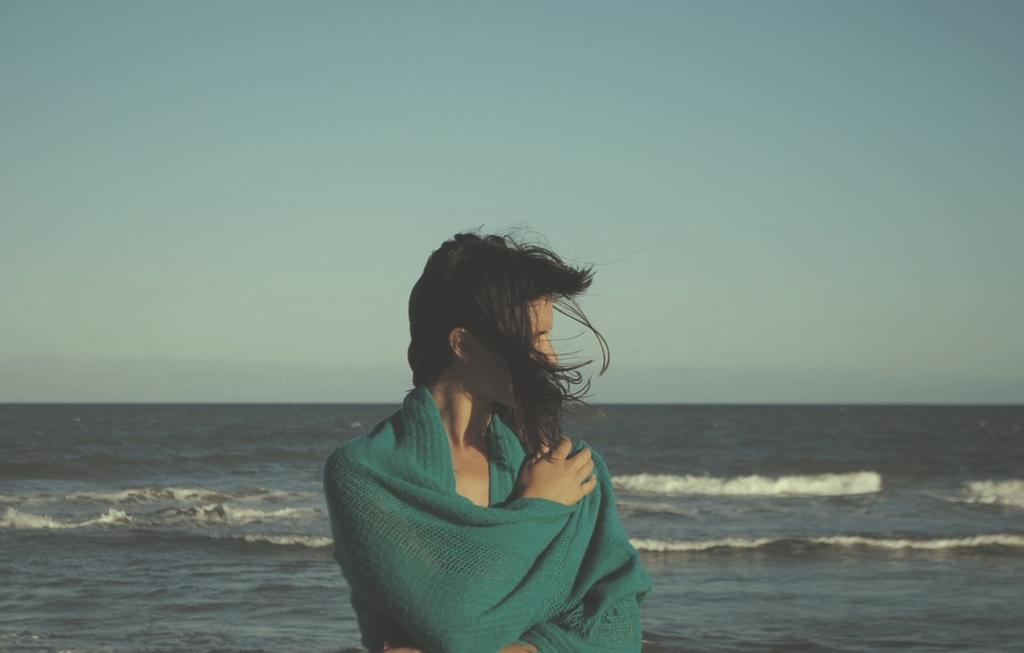Who is the main subject in the image? There is a girl in the image. What is the girl wearing around her neck? The girl is wearing a green scarf. What can be seen in the background of the image? There is a river and the sky visible in the background of the image. What type of copper material is being used in the industry depicted in the image? There is no industry or copper material present in the image; it features a girl wearing a green scarf with a river and sky in the background. 